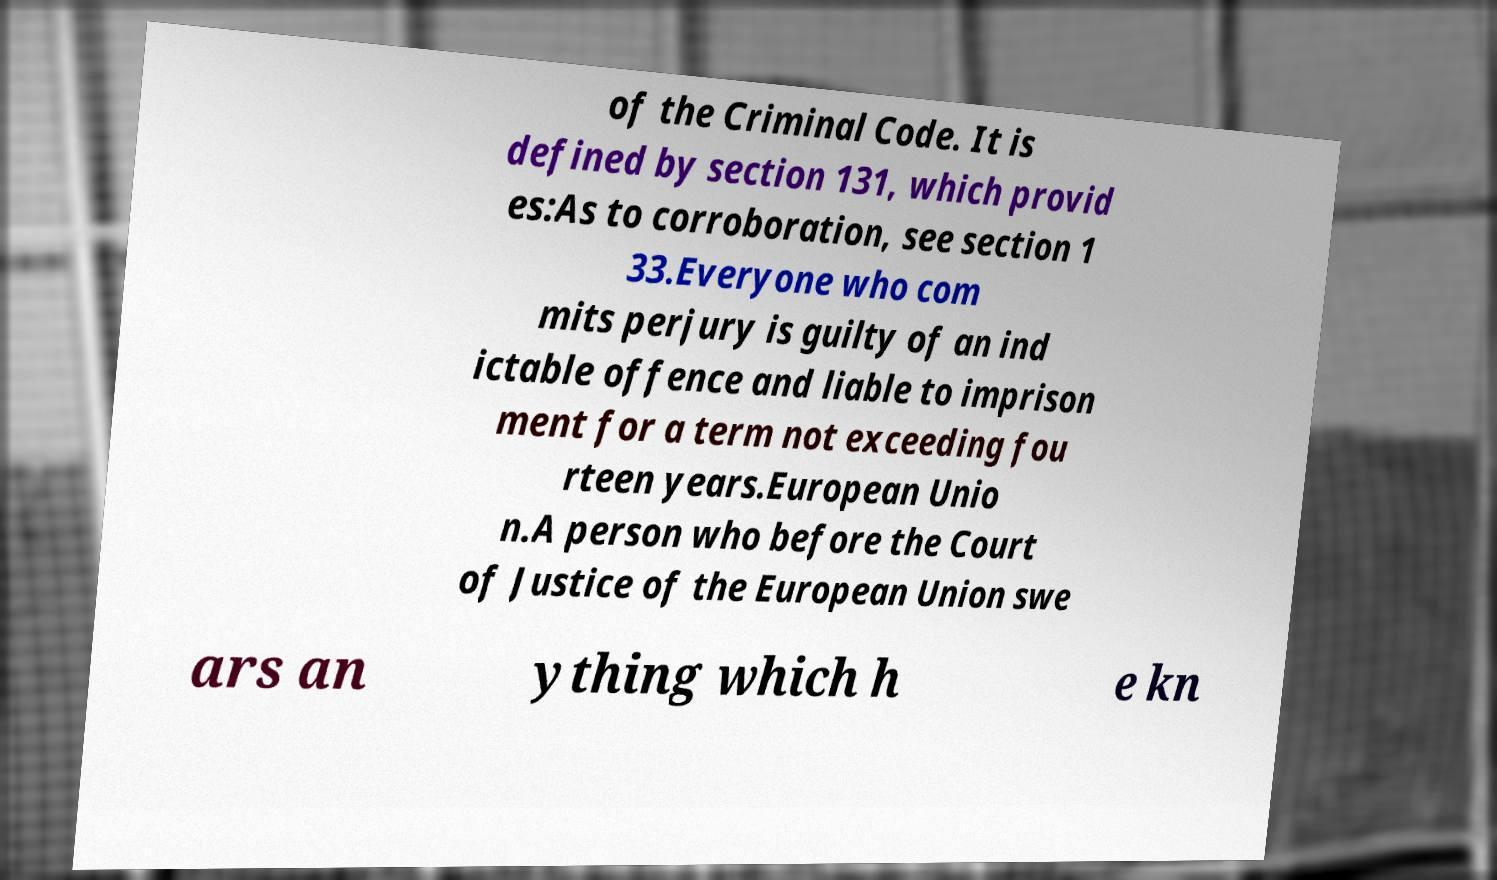Could you assist in decoding the text presented in this image and type it out clearly? of the Criminal Code. It is defined by section 131, which provid es:As to corroboration, see section 1 33.Everyone who com mits perjury is guilty of an ind ictable offence and liable to imprison ment for a term not exceeding fou rteen years.European Unio n.A person who before the Court of Justice of the European Union swe ars an ything which h e kn 